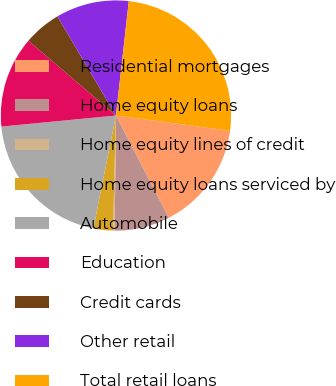Convert chart to OTSL. <chart><loc_0><loc_0><loc_500><loc_500><pie_chart><fcel>Residential mortgages<fcel>Home equity loans<fcel>Home equity lines of credit<fcel>Home equity loans serviced by<fcel>Automobile<fcel>Education<fcel>Credit cards<fcel>Other retail<fcel>Total retail loans<nl><fcel>15.29%<fcel>7.76%<fcel>0.23%<fcel>2.74%<fcel>20.31%<fcel>12.78%<fcel>5.25%<fcel>10.27%<fcel>25.33%<nl></chart> 